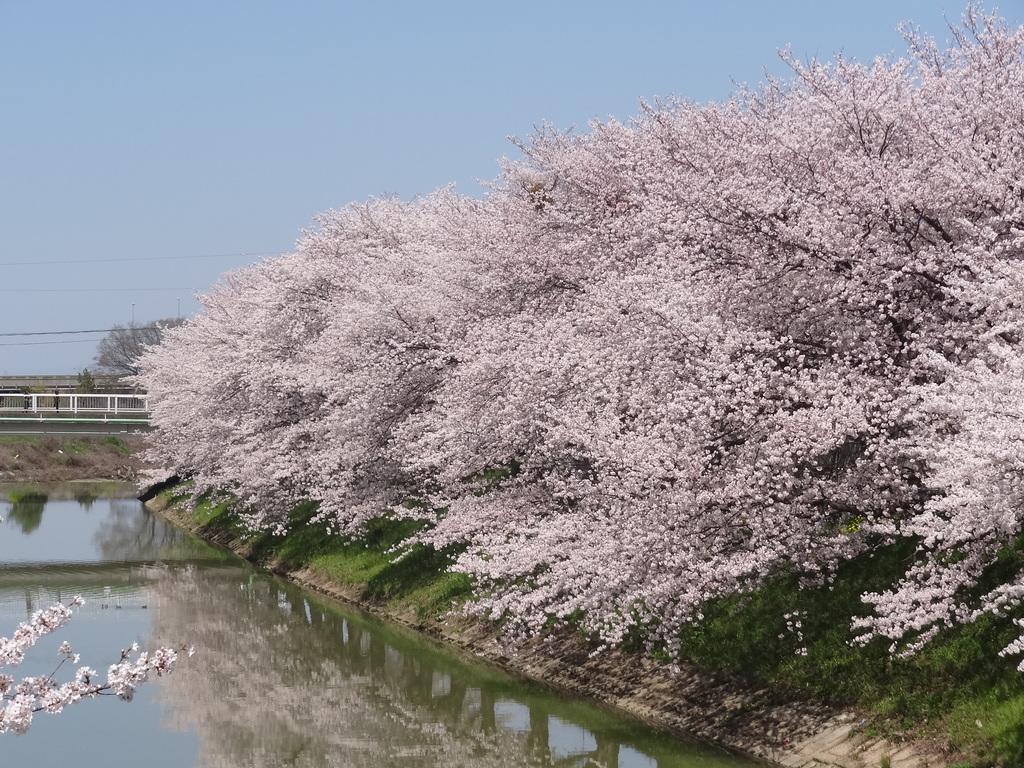Please provide a concise description of this image. In this image there are trees with pink color flowers, water , and in the background there is sky. 